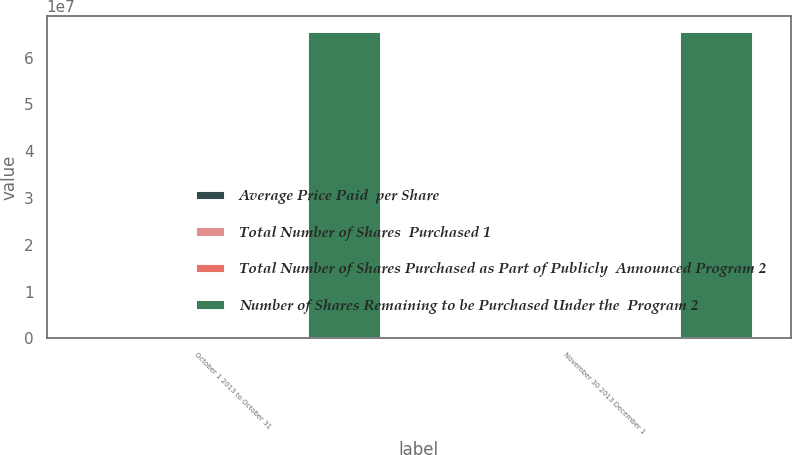Convert chart to OTSL. <chart><loc_0><loc_0><loc_500><loc_500><stacked_bar_chart><ecel><fcel>October 1 2013 to October 31<fcel>November 30 2013 December 1<nl><fcel>Average Price Paid  per Share<fcel>244971<fcel>143<nl><fcel>Total Number of Shares  Purchased 1<fcel>36.82<fcel>40.61<nl><fcel>Total Number of Shares Purchased as Part of Publicly  Announced Program 2<fcel>244971<fcel>143<nl><fcel>Number of Shares Remaining to be Purchased Under the  Program 2<fcel>6.55779e+07<fcel>6.55778e+07<nl></chart> 